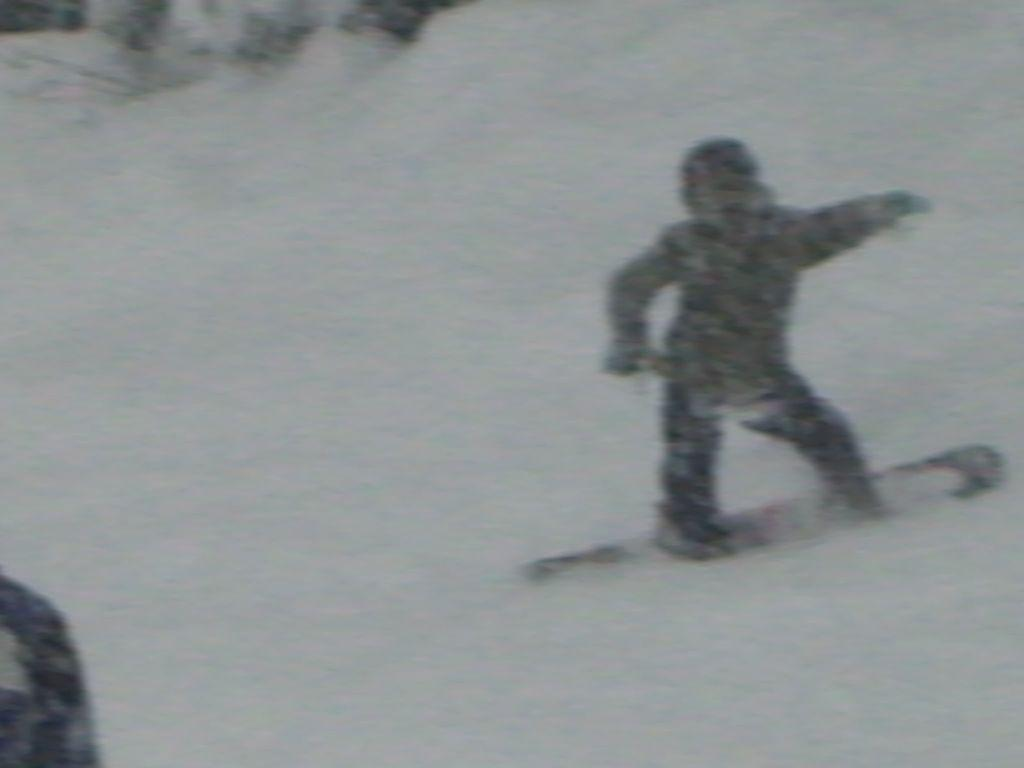What is the main subject of the image? There is a person in the image. What activity is the person engaged in? The person is skating with a snowboard. On what surface is the skating taking place? The skating is taking place on snow. How many bears can be seen in the image? There are no bears present in the image. What type of gold object is visible in the image? There is no gold object present in the image. 